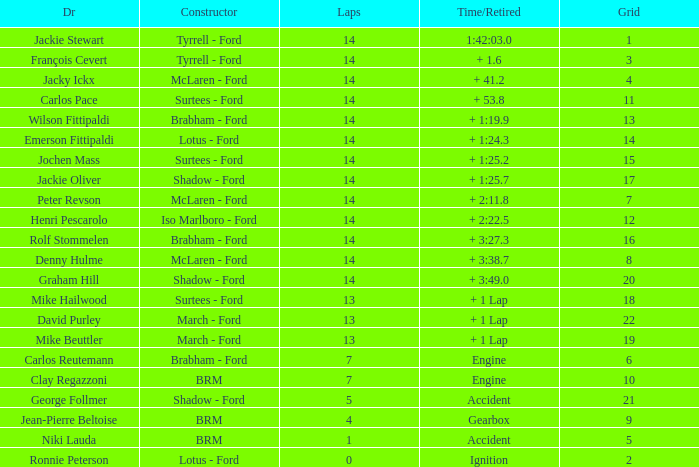What is the low lap total for henri pescarolo with a grad larger than 6? 14.0. 